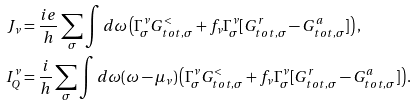<formula> <loc_0><loc_0><loc_500><loc_500>J _ { \nu } & = \frac { i e } { h } \sum _ { \sigma } \int d \omega \left ( \Gamma ^ { \nu } _ { \sigma } G ^ { < } _ { t o t , \sigma } + f _ { \nu } \Gamma ^ { \nu } _ { \sigma } [ G ^ { r } _ { t o t , \sigma } - G ^ { a } _ { t o t , \sigma } ] \right ) , \\ I ^ { \nu } _ { Q } & = \frac { i } { h } \sum _ { \sigma } \int d \omega ( \omega - \mu _ { \nu } ) \left ( \Gamma ^ { \nu } _ { \sigma } G ^ { < } _ { t o t , \sigma } + f _ { \nu } \Gamma ^ { \nu } _ { \sigma } [ G ^ { r } _ { t o t , \sigma } - G ^ { a } _ { t o t , \sigma } ] \right ) .</formula> 